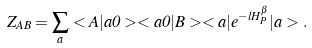Convert formula to latex. <formula><loc_0><loc_0><loc_500><loc_500>Z _ { A B } = \sum _ { a } < A | a 0 > < a 0 | B > < a | e ^ { - l H ^ { \beta } _ { P } } | a > .</formula> 